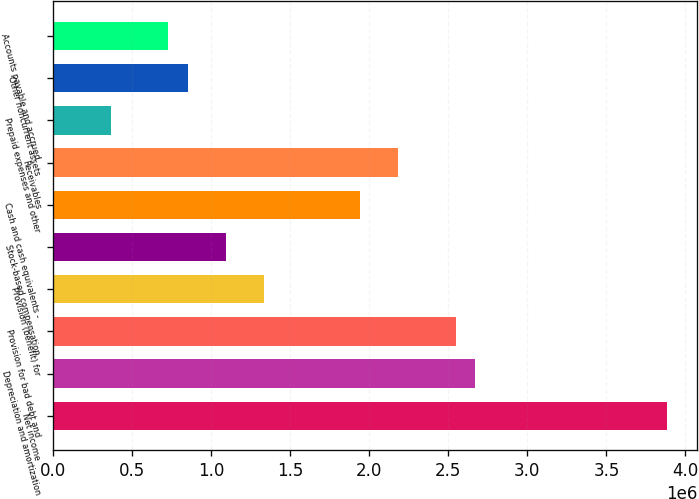Convert chart. <chart><loc_0><loc_0><loc_500><loc_500><bar_chart><fcel>Net income<fcel>Depreciation and amortization<fcel>Provision for bad debt and<fcel>Provision (benefit) for<fcel>Stock-based compensation<fcel>Cash and cash equivalents -<fcel>Receivables<fcel>Prepaid expenses and other<fcel>Other noncurrent assets<fcel>Accounts payable and accrued<nl><fcel>3.88212e+06<fcel>2.66945e+06<fcel>2.54818e+06<fcel>1.33551e+06<fcel>1.09297e+06<fcel>1.94184e+06<fcel>2.18438e+06<fcel>365366<fcel>850436<fcel>729168<nl></chart> 